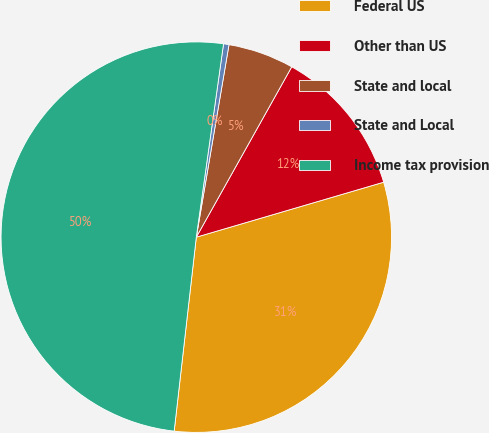<chart> <loc_0><loc_0><loc_500><loc_500><pie_chart><fcel>Federal US<fcel>Other than US<fcel>State and local<fcel>State and Local<fcel>Income tax provision<nl><fcel>31.35%<fcel>12.33%<fcel>5.45%<fcel>0.45%<fcel>50.42%<nl></chart> 